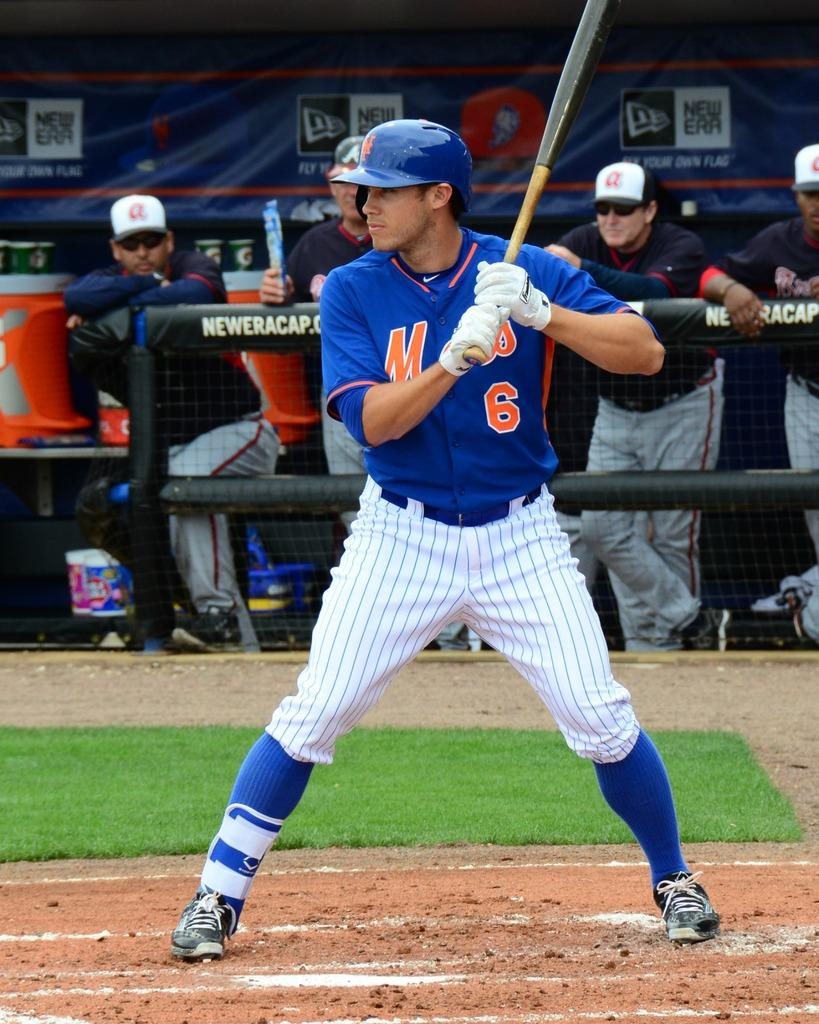<image>
Render a clear and concise summary of the photo. A baseball players stands at-bat, wearing the number 6 on his jersey. 